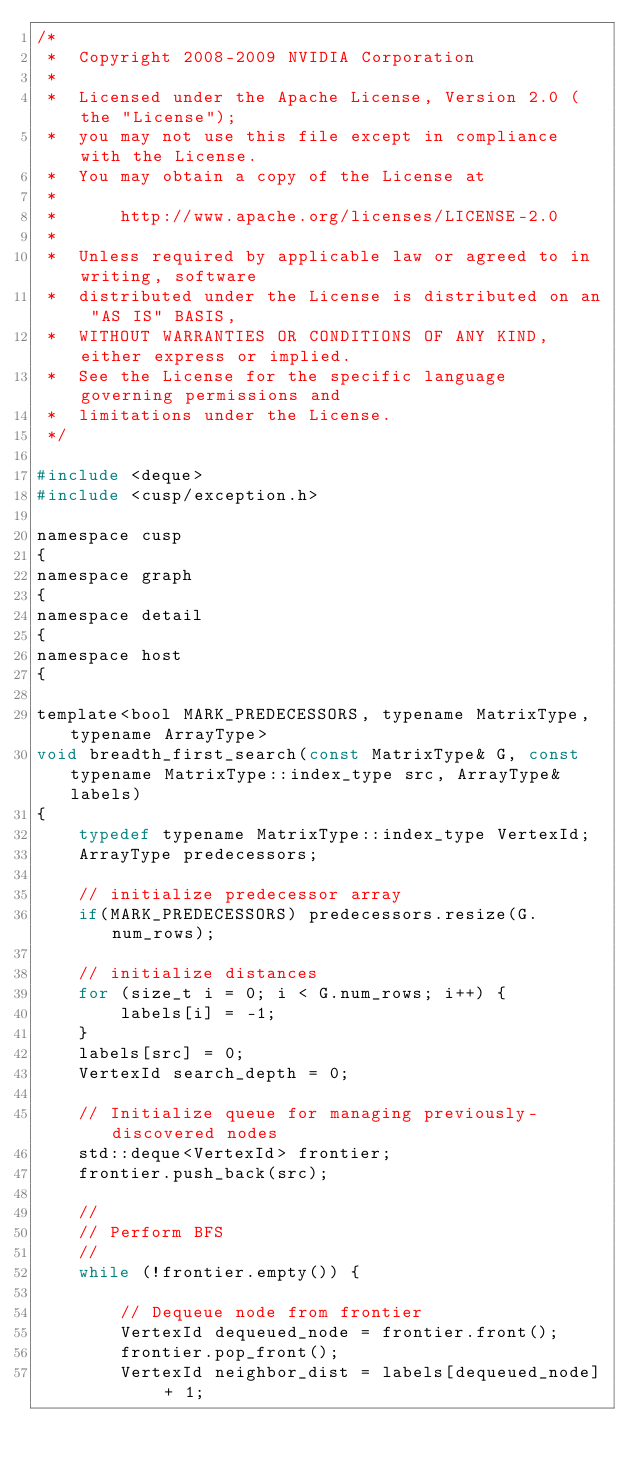<code> <loc_0><loc_0><loc_500><loc_500><_C_>/*
 *  Copyright 2008-2009 NVIDIA Corporation
 *
 *  Licensed under the Apache License, Version 2.0 (the "License");
 *  you may not use this file except in compliance with the License.
 *  You may obtain a copy of the License at
 *
 *      http://www.apache.org/licenses/LICENSE-2.0
 *
 *  Unless required by applicable law or agreed to in writing, software
 *  distributed under the License is distributed on an "AS IS" BASIS,
 *  WITHOUT WARRANTIES OR CONDITIONS OF ANY KIND, either express or implied.
 *  See the License for the specific language governing permissions and
 *  limitations under the License.
 */

#include <deque>
#include <cusp/exception.h>

namespace cusp
{
namespace graph
{
namespace detail
{
namespace host
{

template<bool MARK_PREDECESSORS, typename MatrixType, typename ArrayType>
void breadth_first_search(const MatrixType& G, const typename MatrixType::index_type src, ArrayType& labels)
{
    typedef typename MatrixType::index_type VertexId;
    ArrayType predecessors;

    // initialize predecessor array
    if(MARK_PREDECESSORS) predecessors.resize(G.num_rows);

    // initialize distances
    for (size_t i = 0; i < G.num_rows; i++) {
        labels[i] = -1;
    }
    labels[src] = 0;
    VertexId search_depth = 0;

    // Initialize queue for managing previously-discovered nodes
    std::deque<VertexId> frontier;
    frontier.push_back(src);

    //
    // Perform BFS
    //
    while (!frontier.empty()) {

        // Dequeue node from frontier
        VertexId dequeued_node = frontier.front();
        frontier.pop_front();
        VertexId neighbor_dist = labels[dequeued_node] + 1;
</code> 